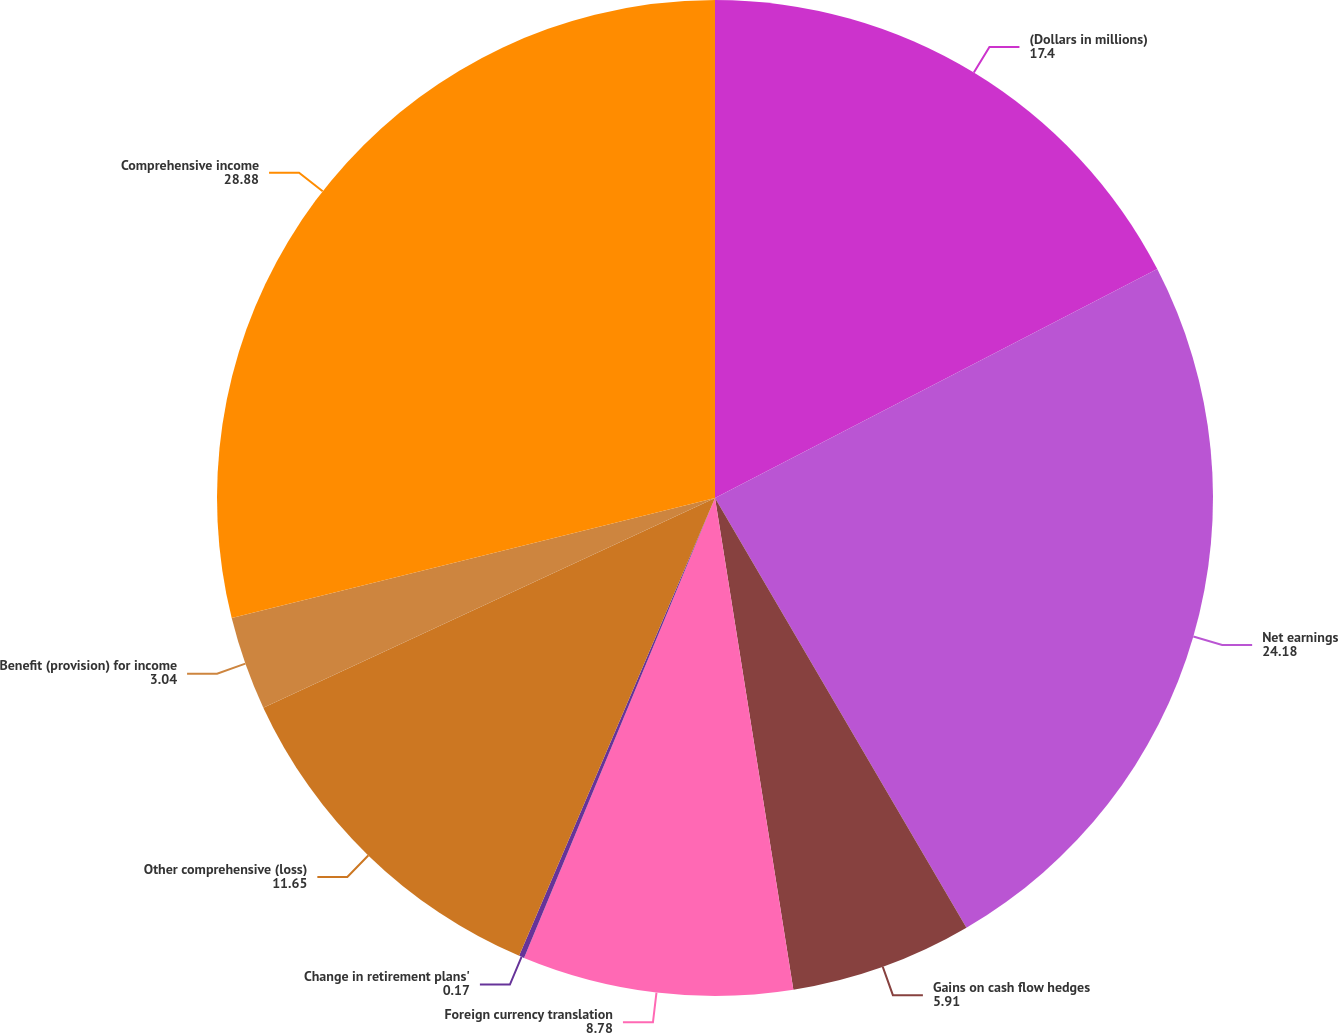Convert chart to OTSL. <chart><loc_0><loc_0><loc_500><loc_500><pie_chart><fcel>(Dollars in millions)<fcel>Net earnings<fcel>Gains on cash flow hedges<fcel>Foreign currency translation<fcel>Change in retirement plans'<fcel>Other comprehensive (loss)<fcel>Benefit (provision) for income<fcel>Comprehensive income<nl><fcel>17.4%<fcel>24.18%<fcel>5.91%<fcel>8.78%<fcel>0.17%<fcel>11.65%<fcel>3.04%<fcel>28.88%<nl></chart> 